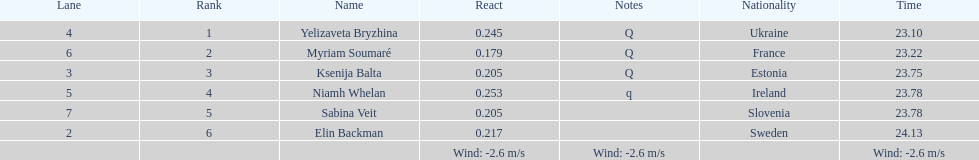How long did it take elin backman to finish the race? 24.13. 